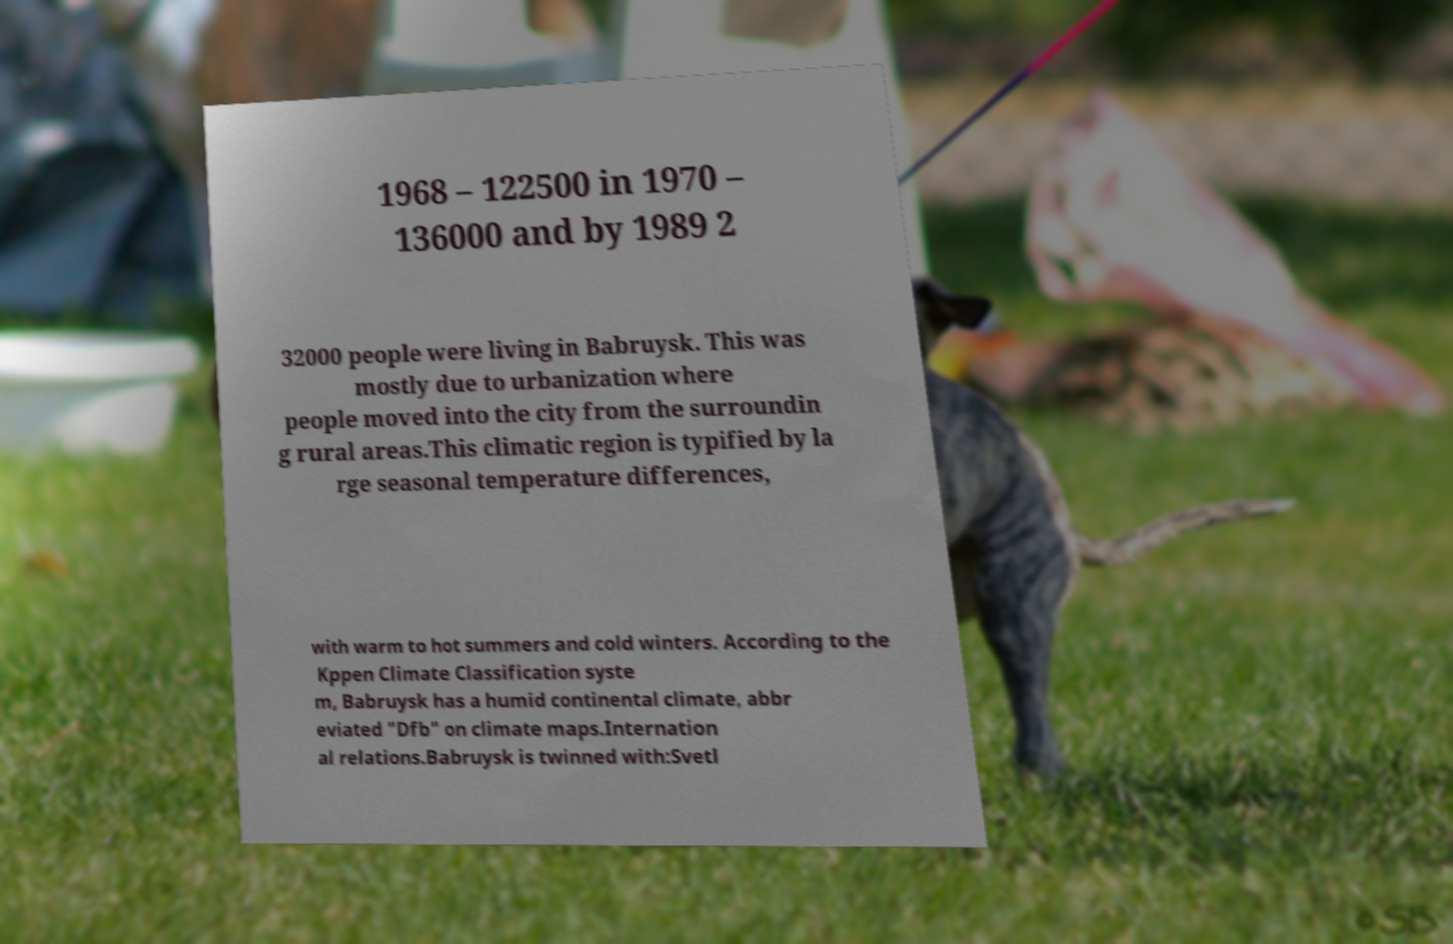Can you read and provide the text displayed in the image?This photo seems to have some interesting text. Can you extract and type it out for me? 1968 – 122500 in 1970 – 136000 and by 1989 2 32000 people were living in Babruysk. This was mostly due to urbanization where people moved into the city from the surroundin g rural areas.This climatic region is typified by la rge seasonal temperature differences, with warm to hot summers and cold winters. According to the Kppen Climate Classification syste m, Babruysk has a humid continental climate, abbr eviated "Dfb" on climate maps.Internation al relations.Babruysk is twinned with:Svetl 